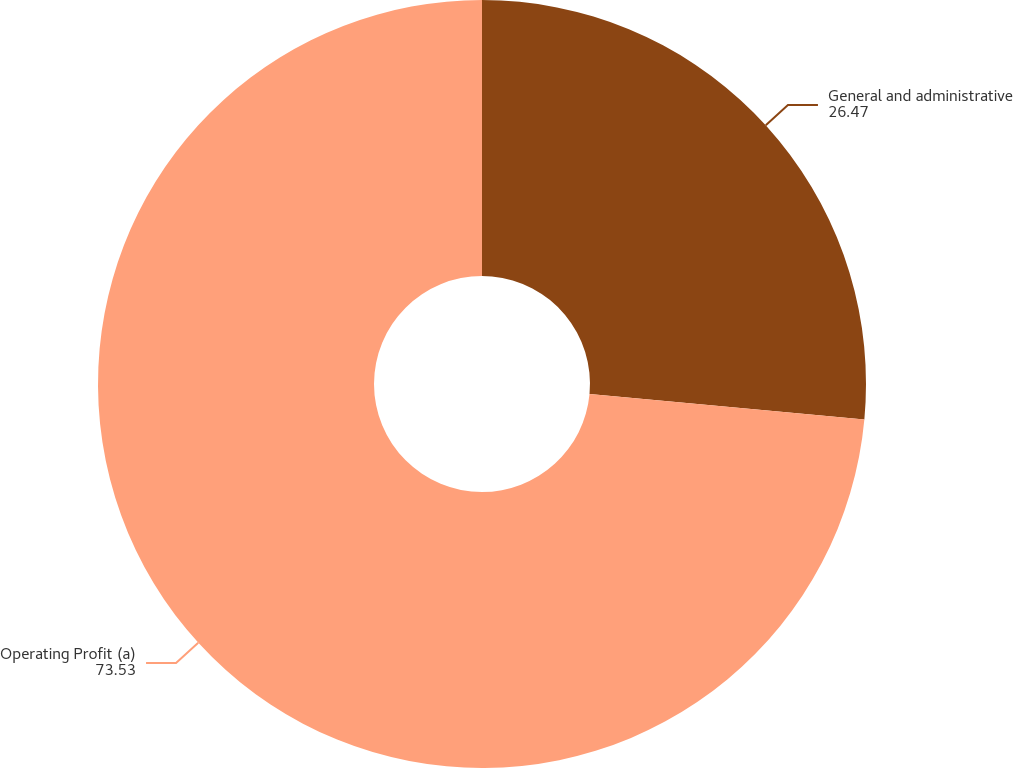Convert chart to OTSL. <chart><loc_0><loc_0><loc_500><loc_500><pie_chart><fcel>General and administrative<fcel>Operating Profit (a)<nl><fcel>26.47%<fcel>73.53%<nl></chart> 